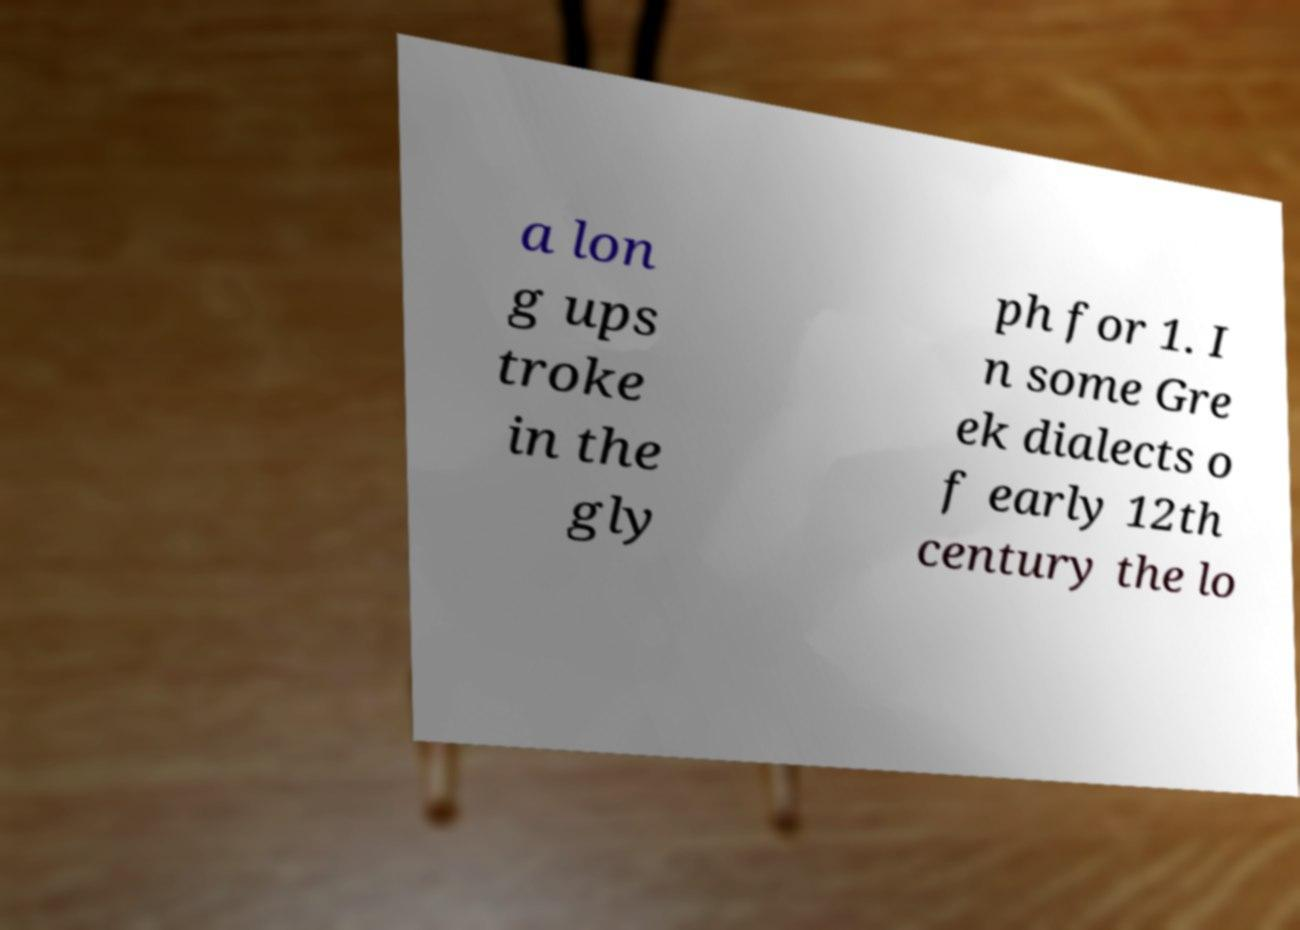Can you read and provide the text displayed in the image?This photo seems to have some interesting text. Can you extract and type it out for me? a lon g ups troke in the gly ph for 1. I n some Gre ek dialects o f early 12th century the lo 